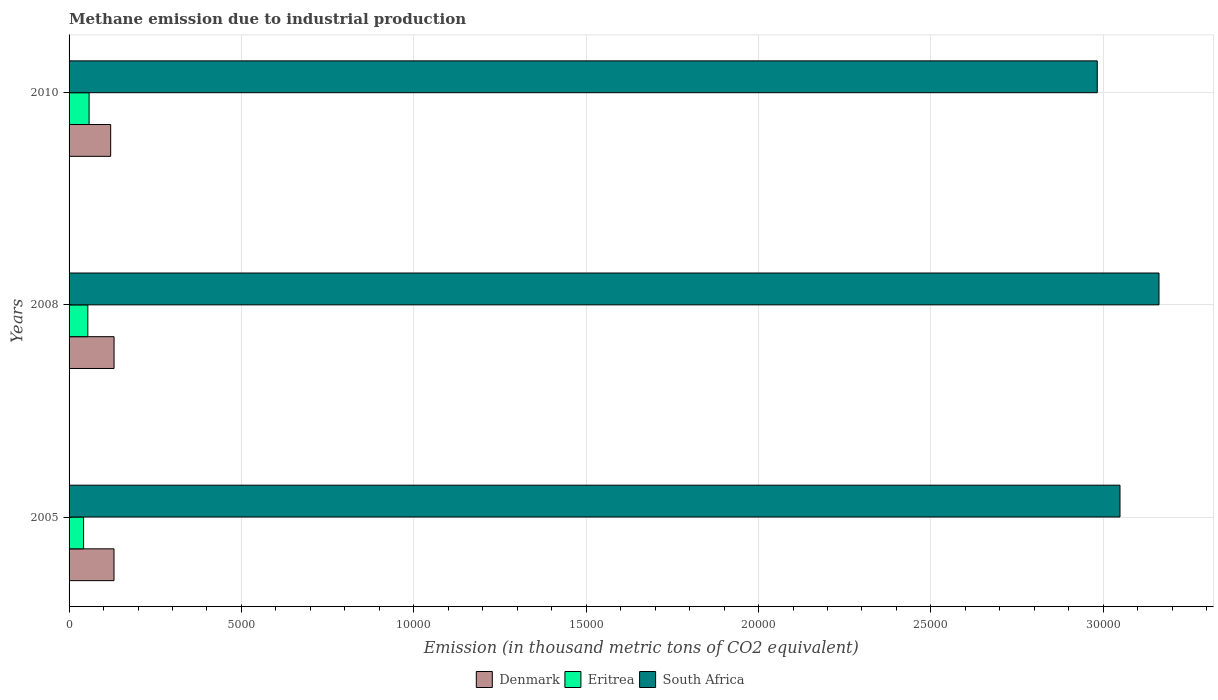How many bars are there on the 1st tick from the top?
Offer a very short reply. 3. How many bars are there on the 1st tick from the bottom?
Provide a succinct answer. 3. What is the amount of methane emitted in South Africa in 2010?
Give a very brief answer. 2.98e+04. Across all years, what is the maximum amount of methane emitted in Eritrea?
Your answer should be compact. 580.9. Across all years, what is the minimum amount of methane emitted in South Africa?
Make the answer very short. 2.98e+04. In which year was the amount of methane emitted in Eritrea maximum?
Your answer should be very brief. 2010. In which year was the amount of methane emitted in Eritrea minimum?
Offer a terse response. 2005. What is the total amount of methane emitted in South Africa in the graph?
Keep it short and to the point. 9.19e+04. What is the difference between the amount of methane emitted in Eritrea in 2005 and that in 2008?
Provide a short and direct response. -122.8. What is the difference between the amount of methane emitted in South Africa in 2005 and the amount of methane emitted in Eritrea in 2008?
Ensure brevity in your answer.  2.99e+04. What is the average amount of methane emitted in Denmark per year?
Your answer should be compact. 1271.6. In the year 2008, what is the difference between the amount of methane emitted in Eritrea and amount of methane emitted in Denmark?
Keep it short and to the point. -760.7. What is the ratio of the amount of methane emitted in Denmark in 2005 to that in 2008?
Provide a short and direct response. 1. Is the difference between the amount of methane emitted in Eritrea in 2008 and 2010 greater than the difference between the amount of methane emitted in Denmark in 2008 and 2010?
Make the answer very short. No. What is the difference between the highest and the second highest amount of methane emitted in Denmark?
Keep it short and to the point. 1.8. What is the difference between the highest and the lowest amount of methane emitted in Denmark?
Ensure brevity in your answer.  98.1. What does the 2nd bar from the top in 2008 represents?
Your answer should be compact. Eritrea. What does the 3rd bar from the bottom in 2008 represents?
Provide a succinct answer. South Africa. Are all the bars in the graph horizontal?
Provide a succinct answer. Yes. How many years are there in the graph?
Offer a terse response. 3. Are the values on the major ticks of X-axis written in scientific E-notation?
Keep it short and to the point. No. Where does the legend appear in the graph?
Keep it short and to the point. Bottom center. How many legend labels are there?
Offer a terse response. 3. What is the title of the graph?
Provide a succinct answer. Methane emission due to industrial production. What is the label or title of the X-axis?
Keep it short and to the point. Emission (in thousand metric tons of CO2 equivalent). What is the label or title of the Y-axis?
Your response must be concise. Years. What is the Emission (in thousand metric tons of CO2 equivalent) in Denmark in 2005?
Offer a terse response. 1303.1. What is the Emission (in thousand metric tons of CO2 equivalent) of Eritrea in 2005?
Your answer should be compact. 421.4. What is the Emission (in thousand metric tons of CO2 equivalent) in South Africa in 2005?
Give a very brief answer. 3.05e+04. What is the Emission (in thousand metric tons of CO2 equivalent) of Denmark in 2008?
Ensure brevity in your answer.  1304.9. What is the Emission (in thousand metric tons of CO2 equivalent) of Eritrea in 2008?
Ensure brevity in your answer.  544.2. What is the Emission (in thousand metric tons of CO2 equivalent) in South Africa in 2008?
Make the answer very short. 3.16e+04. What is the Emission (in thousand metric tons of CO2 equivalent) of Denmark in 2010?
Keep it short and to the point. 1206.8. What is the Emission (in thousand metric tons of CO2 equivalent) in Eritrea in 2010?
Your answer should be very brief. 580.9. What is the Emission (in thousand metric tons of CO2 equivalent) of South Africa in 2010?
Ensure brevity in your answer.  2.98e+04. Across all years, what is the maximum Emission (in thousand metric tons of CO2 equivalent) of Denmark?
Your answer should be compact. 1304.9. Across all years, what is the maximum Emission (in thousand metric tons of CO2 equivalent) of Eritrea?
Offer a very short reply. 580.9. Across all years, what is the maximum Emission (in thousand metric tons of CO2 equivalent) of South Africa?
Provide a succinct answer. 3.16e+04. Across all years, what is the minimum Emission (in thousand metric tons of CO2 equivalent) of Denmark?
Ensure brevity in your answer.  1206.8. Across all years, what is the minimum Emission (in thousand metric tons of CO2 equivalent) in Eritrea?
Make the answer very short. 421.4. Across all years, what is the minimum Emission (in thousand metric tons of CO2 equivalent) of South Africa?
Make the answer very short. 2.98e+04. What is the total Emission (in thousand metric tons of CO2 equivalent) in Denmark in the graph?
Provide a succinct answer. 3814.8. What is the total Emission (in thousand metric tons of CO2 equivalent) of Eritrea in the graph?
Give a very brief answer. 1546.5. What is the total Emission (in thousand metric tons of CO2 equivalent) in South Africa in the graph?
Give a very brief answer. 9.19e+04. What is the difference between the Emission (in thousand metric tons of CO2 equivalent) in Eritrea in 2005 and that in 2008?
Make the answer very short. -122.8. What is the difference between the Emission (in thousand metric tons of CO2 equivalent) in South Africa in 2005 and that in 2008?
Your answer should be very brief. -1131.1. What is the difference between the Emission (in thousand metric tons of CO2 equivalent) in Denmark in 2005 and that in 2010?
Ensure brevity in your answer.  96.3. What is the difference between the Emission (in thousand metric tons of CO2 equivalent) of Eritrea in 2005 and that in 2010?
Offer a terse response. -159.5. What is the difference between the Emission (in thousand metric tons of CO2 equivalent) in South Africa in 2005 and that in 2010?
Ensure brevity in your answer.  659.6. What is the difference between the Emission (in thousand metric tons of CO2 equivalent) of Denmark in 2008 and that in 2010?
Make the answer very short. 98.1. What is the difference between the Emission (in thousand metric tons of CO2 equivalent) in Eritrea in 2008 and that in 2010?
Provide a short and direct response. -36.7. What is the difference between the Emission (in thousand metric tons of CO2 equivalent) of South Africa in 2008 and that in 2010?
Provide a succinct answer. 1790.7. What is the difference between the Emission (in thousand metric tons of CO2 equivalent) of Denmark in 2005 and the Emission (in thousand metric tons of CO2 equivalent) of Eritrea in 2008?
Your response must be concise. 758.9. What is the difference between the Emission (in thousand metric tons of CO2 equivalent) in Denmark in 2005 and the Emission (in thousand metric tons of CO2 equivalent) in South Africa in 2008?
Offer a very short reply. -3.03e+04. What is the difference between the Emission (in thousand metric tons of CO2 equivalent) in Eritrea in 2005 and the Emission (in thousand metric tons of CO2 equivalent) in South Africa in 2008?
Your answer should be very brief. -3.12e+04. What is the difference between the Emission (in thousand metric tons of CO2 equivalent) in Denmark in 2005 and the Emission (in thousand metric tons of CO2 equivalent) in Eritrea in 2010?
Ensure brevity in your answer.  722.2. What is the difference between the Emission (in thousand metric tons of CO2 equivalent) of Denmark in 2005 and the Emission (in thousand metric tons of CO2 equivalent) of South Africa in 2010?
Offer a very short reply. -2.85e+04. What is the difference between the Emission (in thousand metric tons of CO2 equivalent) of Eritrea in 2005 and the Emission (in thousand metric tons of CO2 equivalent) of South Africa in 2010?
Offer a very short reply. -2.94e+04. What is the difference between the Emission (in thousand metric tons of CO2 equivalent) in Denmark in 2008 and the Emission (in thousand metric tons of CO2 equivalent) in Eritrea in 2010?
Make the answer very short. 724. What is the difference between the Emission (in thousand metric tons of CO2 equivalent) in Denmark in 2008 and the Emission (in thousand metric tons of CO2 equivalent) in South Africa in 2010?
Offer a terse response. -2.85e+04. What is the difference between the Emission (in thousand metric tons of CO2 equivalent) in Eritrea in 2008 and the Emission (in thousand metric tons of CO2 equivalent) in South Africa in 2010?
Provide a short and direct response. -2.93e+04. What is the average Emission (in thousand metric tons of CO2 equivalent) of Denmark per year?
Offer a very short reply. 1271.6. What is the average Emission (in thousand metric tons of CO2 equivalent) in Eritrea per year?
Offer a terse response. 515.5. What is the average Emission (in thousand metric tons of CO2 equivalent) of South Africa per year?
Your response must be concise. 3.06e+04. In the year 2005, what is the difference between the Emission (in thousand metric tons of CO2 equivalent) of Denmark and Emission (in thousand metric tons of CO2 equivalent) of Eritrea?
Offer a terse response. 881.7. In the year 2005, what is the difference between the Emission (in thousand metric tons of CO2 equivalent) of Denmark and Emission (in thousand metric tons of CO2 equivalent) of South Africa?
Your answer should be compact. -2.92e+04. In the year 2005, what is the difference between the Emission (in thousand metric tons of CO2 equivalent) of Eritrea and Emission (in thousand metric tons of CO2 equivalent) of South Africa?
Ensure brevity in your answer.  -3.01e+04. In the year 2008, what is the difference between the Emission (in thousand metric tons of CO2 equivalent) in Denmark and Emission (in thousand metric tons of CO2 equivalent) in Eritrea?
Your answer should be very brief. 760.7. In the year 2008, what is the difference between the Emission (in thousand metric tons of CO2 equivalent) in Denmark and Emission (in thousand metric tons of CO2 equivalent) in South Africa?
Your answer should be compact. -3.03e+04. In the year 2008, what is the difference between the Emission (in thousand metric tons of CO2 equivalent) of Eritrea and Emission (in thousand metric tons of CO2 equivalent) of South Africa?
Ensure brevity in your answer.  -3.11e+04. In the year 2010, what is the difference between the Emission (in thousand metric tons of CO2 equivalent) in Denmark and Emission (in thousand metric tons of CO2 equivalent) in Eritrea?
Provide a succinct answer. 625.9. In the year 2010, what is the difference between the Emission (in thousand metric tons of CO2 equivalent) in Denmark and Emission (in thousand metric tons of CO2 equivalent) in South Africa?
Provide a short and direct response. -2.86e+04. In the year 2010, what is the difference between the Emission (in thousand metric tons of CO2 equivalent) of Eritrea and Emission (in thousand metric tons of CO2 equivalent) of South Africa?
Your answer should be very brief. -2.92e+04. What is the ratio of the Emission (in thousand metric tons of CO2 equivalent) in Denmark in 2005 to that in 2008?
Your answer should be compact. 1. What is the ratio of the Emission (in thousand metric tons of CO2 equivalent) in Eritrea in 2005 to that in 2008?
Your answer should be very brief. 0.77. What is the ratio of the Emission (in thousand metric tons of CO2 equivalent) of South Africa in 2005 to that in 2008?
Offer a terse response. 0.96. What is the ratio of the Emission (in thousand metric tons of CO2 equivalent) of Denmark in 2005 to that in 2010?
Give a very brief answer. 1.08. What is the ratio of the Emission (in thousand metric tons of CO2 equivalent) of Eritrea in 2005 to that in 2010?
Your answer should be compact. 0.73. What is the ratio of the Emission (in thousand metric tons of CO2 equivalent) of South Africa in 2005 to that in 2010?
Your answer should be very brief. 1.02. What is the ratio of the Emission (in thousand metric tons of CO2 equivalent) of Denmark in 2008 to that in 2010?
Your answer should be compact. 1.08. What is the ratio of the Emission (in thousand metric tons of CO2 equivalent) in Eritrea in 2008 to that in 2010?
Provide a succinct answer. 0.94. What is the ratio of the Emission (in thousand metric tons of CO2 equivalent) in South Africa in 2008 to that in 2010?
Provide a short and direct response. 1.06. What is the difference between the highest and the second highest Emission (in thousand metric tons of CO2 equivalent) of Eritrea?
Keep it short and to the point. 36.7. What is the difference between the highest and the second highest Emission (in thousand metric tons of CO2 equivalent) of South Africa?
Offer a terse response. 1131.1. What is the difference between the highest and the lowest Emission (in thousand metric tons of CO2 equivalent) of Denmark?
Give a very brief answer. 98.1. What is the difference between the highest and the lowest Emission (in thousand metric tons of CO2 equivalent) in Eritrea?
Your answer should be very brief. 159.5. What is the difference between the highest and the lowest Emission (in thousand metric tons of CO2 equivalent) in South Africa?
Make the answer very short. 1790.7. 